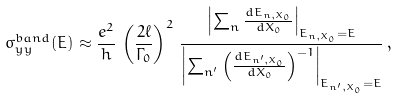Convert formula to latex. <formula><loc_0><loc_0><loc_500><loc_500>\sigma _ { y y } ^ { b a n d } ( E ) \approx \frac { e ^ { 2 } } { h } \, \left ( \frac { 2 \ell } { \Gamma _ { 0 } } \right ) ^ { 2 } \, \frac { \left | \sum _ { n } \frac { d E _ { n , X _ { 0 } } } { d X _ { 0 } } \right | _ { E _ { n , X _ { 0 } } = E } } { \left | \sum _ { n ^ { \prime } } \left ( \frac { d E _ { n ^ { \prime } , X _ { 0 } } } { d X _ { 0 } } \right ) ^ { - 1 } \right | _ { E _ { n ^ { \prime } , X _ { 0 } } = E } } \, ,</formula> 